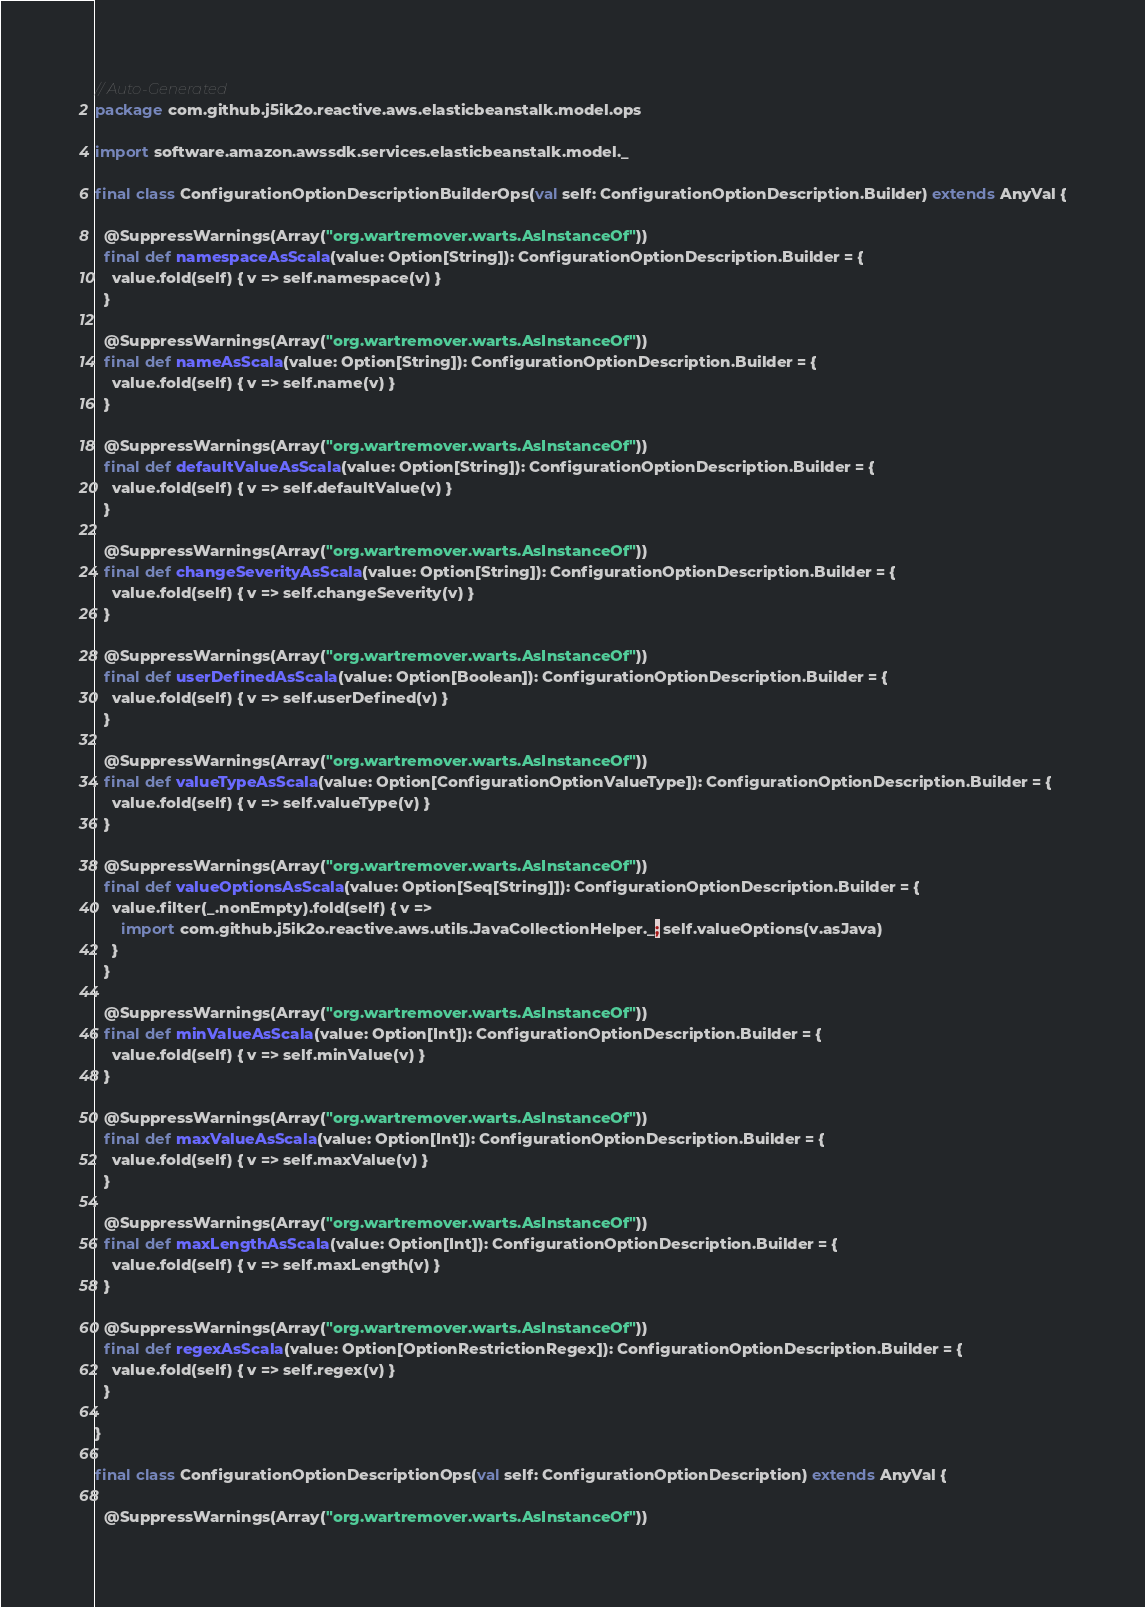Convert code to text. <code><loc_0><loc_0><loc_500><loc_500><_Scala_>// Auto-Generated
package com.github.j5ik2o.reactive.aws.elasticbeanstalk.model.ops

import software.amazon.awssdk.services.elasticbeanstalk.model._

final class ConfigurationOptionDescriptionBuilderOps(val self: ConfigurationOptionDescription.Builder) extends AnyVal {

  @SuppressWarnings(Array("org.wartremover.warts.AsInstanceOf"))
  final def namespaceAsScala(value: Option[String]): ConfigurationOptionDescription.Builder = {
    value.fold(self) { v => self.namespace(v) }
  }

  @SuppressWarnings(Array("org.wartremover.warts.AsInstanceOf"))
  final def nameAsScala(value: Option[String]): ConfigurationOptionDescription.Builder = {
    value.fold(self) { v => self.name(v) }
  }

  @SuppressWarnings(Array("org.wartremover.warts.AsInstanceOf"))
  final def defaultValueAsScala(value: Option[String]): ConfigurationOptionDescription.Builder = {
    value.fold(self) { v => self.defaultValue(v) }
  }

  @SuppressWarnings(Array("org.wartremover.warts.AsInstanceOf"))
  final def changeSeverityAsScala(value: Option[String]): ConfigurationOptionDescription.Builder = {
    value.fold(self) { v => self.changeSeverity(v) }
  }

  @SuppressWarnings(Array("org.wartremover.warts.AsInstanceOf"))
  final def userDefinedAsScala(value: Option[Boolean]): ConfigurationOptionDescription.Builder = {
    value.fold(self) { v => self.userDefined(v) }
  }

  @SuppressWarnings(Array("org.wartremover.warts.AsInstanceOf"))
  final def valueTypeAsScala(value: Option[ConfigurationOptionValueType]): ConfigurationOptionDescription.Builder = {
    value.fold(self) { v => self.valueType(v) }
  }

  @SuppressWarnings(Array("org.wartremover.warts.AsInstanceOf"))
  final def valueOptionsAsScala(value: Option[Seq[String]]): ConfigurationOptionDescription.Builder = {
    value.filter(_.nonEmpty).fold(self) { v =>
      import com.github.j5ik2o.reactive.aws.utils.JavaCollectionHelper._; self.valueOptions(v.asJava)
    }
  }

  @SuppressWarnings(Array("org.wartremover.warts.AsInstanceOf"))
  final def minValueAsScala(value: Option[Int]): ConfigurationOptionDescription.Builder = {
    value.fold(self) { v => self.minValue(v) }
  }

  @SuppressWarnings(Array("org.wartremover.warts.AsInstanceOf"))
  final def maxValueAsScala(value: Option[Int]): ConfigurationOptionDescription.Builder = {
    value.fold(self) { v => self.maxValue(v) }
  }

  @SuppressWarnings(Array("org.wartremover.warts.AsInstanceOf"))
  final def maxLengthAsScala(value: Option[Int]): ConfigurationOptionDescription.Builder = {
    value.fold(self) { v => self.maxLength(v) }
  }

  @SuppressWarnings(Array("org.wartremover.warts.AsInstanceOf"))
  final def regexAsScala(value: Option[OptionRestrictionRegex]): ConfigurationOptionDescription.Builder = {
    value.fold(self) { v => self.regex(v) }
  }

}

final class ConfigurationOptionDescriptionOps(val self: ConfigurationOptionDescription) extends AnyVal {

  @SuppressWarnings(Array("org.wartremover.warts.AsInstanceOf"))</code> 